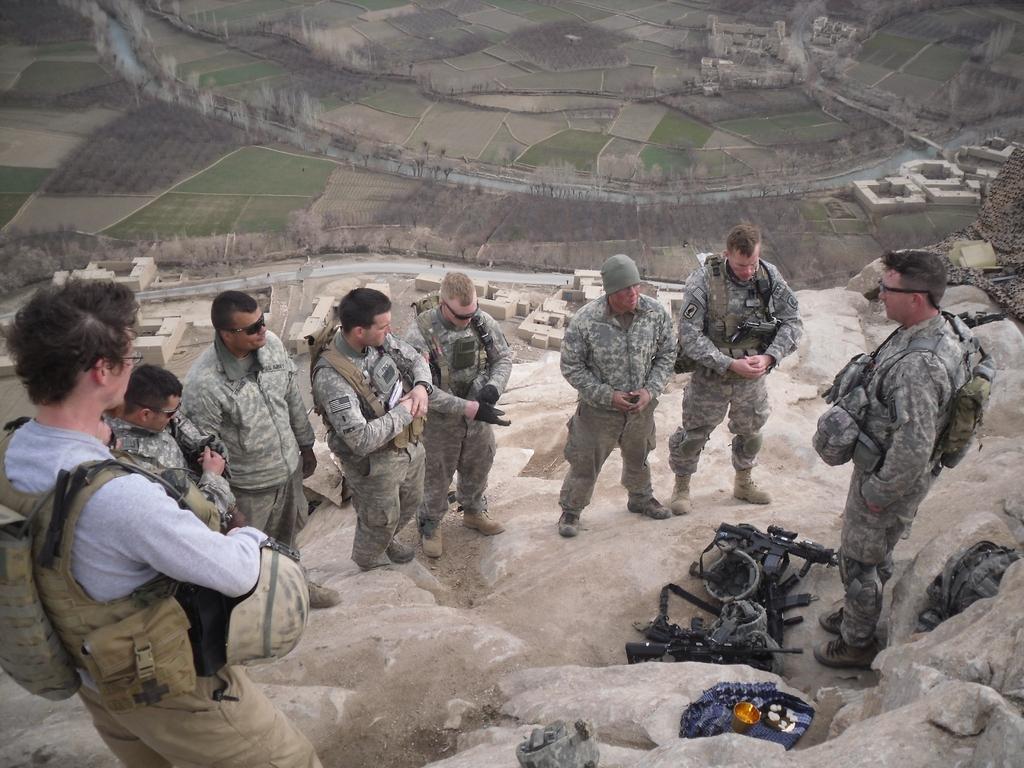How would you summarize this image in a sentence or two? In the picture we can see some group of people wearing camouflage dress standing and there are weapons on ground and in the background of the picture there are some farmlands and houses. 